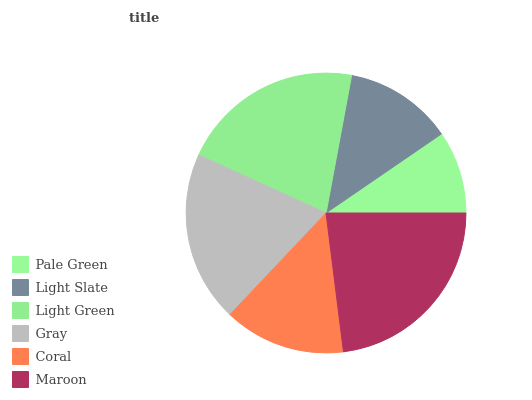Is Pale Green the minimum?
Answer yes or no. Yes. Is Maroon the maximum?
Answer yes or no. Yes. Is Light Slate the minimum?
Answer yes or no. No. Is Light Slate the maximum?
Answer yes or no. No. Is Light Slate greater than Pale Green?
Answer yes or no. Yes. Is Pale Green less than Light Slate?
Answer yes or no. Yes. Is Pale Green greater than Light Slate?
Answer yes or no. No. Is Light Slate less than Pale Green?
Answer yes or no. No. Is Gray the high median?
Answer yes or no. Yes. Is Coral the low median?
Answer yes or no. Yes. Is Pale Green the high median?
Answer yes or no. No. Is Light Green the low median?
Answer yes or no. No. 